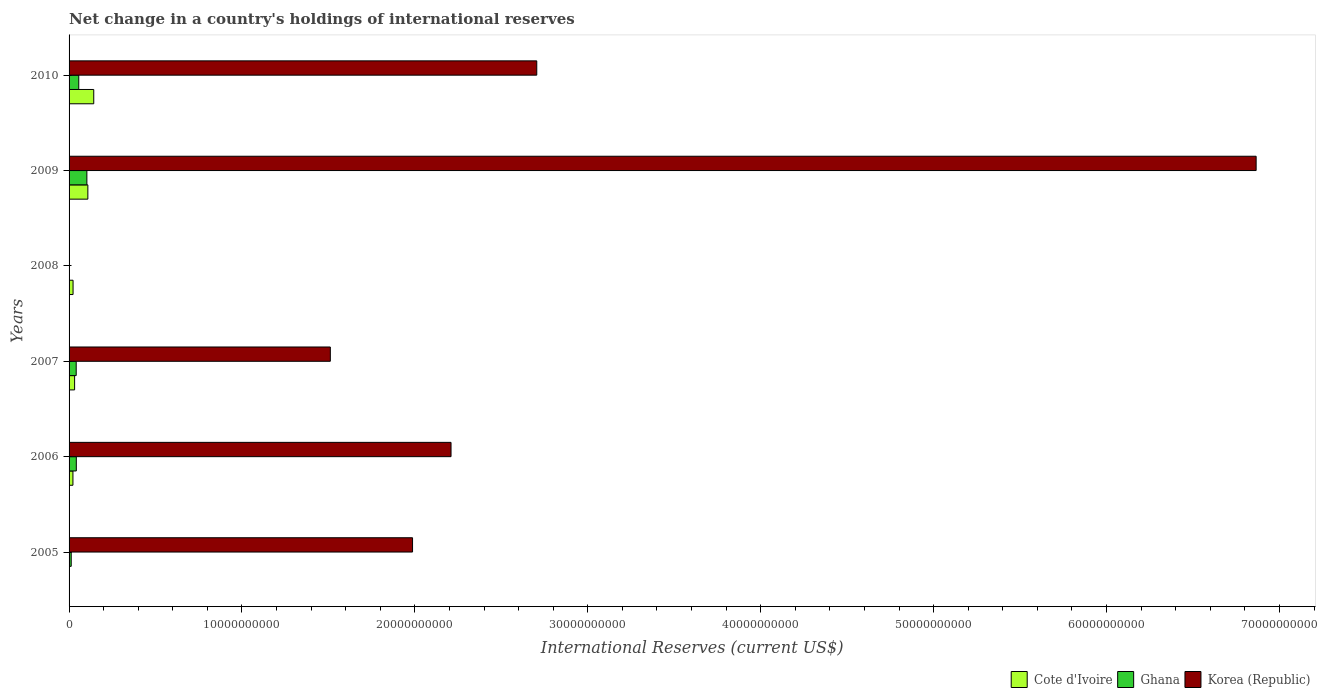How many different coloured bars are there?
Your response must be concise. 3. Are the number of bars per tick equal to the number of legend labels?
Offer a terse response. No. Are the number of bars on each tick of the Y-axis equal?
Your answer should be very brief. No. What is the label of the 3rd group of bars from the top?
Provide a succinct answer. 2008. In how many cases, is the number of bars for a given year not equal to the number of legend labels?
Your answer should be compact. 2. What is the international reserves in Cote d'Ivoire in 2006?
Offer a very short reply. 2.23e+08. Across all years, what is the maximum international reserves in Ghana?
Give a very brief answer. 1.03e+09. Across all years, what is the minimum international reserves in Ghana?
Your response must be concise. 0. What is the total international reserves in Korea (Republic) in the graph?
Make the answer very short. 1.53e+11. What is the difference between the international reserves in Ghana in 2007 and that in 2010?
Offer a very short reply. -1.48e+08. What is the difference between the international reserves in Ghana in 2009 and the international reserves in Cote d'Ivoire in 2008?
Offer a very short reply. 7.99e+08. What is the average international reserves in Cote d'Ivoire per year?
Your answer should be very brief. 5.48e+08. In the year 2010, what is the difference between the international reserves in Korea (Republic) and international reserves in Ghana?
Keep it short and to the point. 2.65e+1. What is the ratio of the international reserves in Ghana in 2007 to that in 2009?
Provide a short and direct response. 0.4. What is the difference between the highest and the second highest international reserves in Korea (Republic)?
Offer a very short reply. 4.16e+1. What is the difference between the highest and the lowest international reserves in Ghana?
Provide a succinct answer. 1.03e+09. In how many years, is the international reserves in Korea (Republic) greater than the average international reserves in Korea (Republic) taken over all years?
Provide a short and direct response. 2. Is it the case that in every year, the sum of the international reserves in Korea (Republic) and international reserves in Ghana is greater than the international reserves in Cote d'Ivoire?
Provide a short and direct response. No. How many bars are there?
Offer a terse response. 15. Are all the bars in the graph horizontal?
Your answer should be very brief. Yes. How many years are there in the graph?
Your answer should be very brief. 6. What is the difference between two consecutive major ticks on the X-axis?
Your answer should be compact. 1.00e+1. Does the graph contain any zero values?
Offer a very short reply. Yes. Does the graph contain grids?
Provide a short and direct response. No. Where does the legend appear in the graph?
Make the answer very short. Bottom right. How are the legend labels stacked?
Keep it short and to the point. Horizontal. What is the title of the graph?
Make the answer very short. Net change in a country's holdings of international reserves. Does "Monaco" appear as one of the legend labels in the graph?
Ensure brevity in your answer.  No. What is the label or title of the X-axis?
Provide a succinct answer. International Reserves (current US$). What is the International Reserves (current US$) of Ghana in 2005?
Ensure brevity in your answer.  1.25e+08. What is the International Reserves (current US$) of Korea (Republic) in 2005?
Give a very brief answer. 1.99e+1. What is the International Reserves (current US$) in Cote d'Ivoire in 2006?
Your response must be concise. 2.23e+08. What is the International Reserves (current US$) in Ghana in 2006?
Provide a succinct answer. 4.18e+08. What is the International Reserves (current US$) in Korea (Republic) in 2006?
Ensure brevity in your answer.  2.21e+1. What is the International Reserves (current US$) of Cote d'Ivoire in 2007?
Give a very brief answer. 3.21e+08. What is the International Reserves (current US$) in Ghana in 2007?
Your answer should be very brief. 4.12e+08. What is the International Reserves (current US$) of Korea (Republic) in 2007?
Ensure brevity in your answer.  1.51e+1. What is the International Reserves (current US$) of Cote d'Ivoire in 2008?
Your answer should be very brief. 2.30e+08. What is the International Reserves (current US$) in Ghana in 2008?
Ensure brevity in your answer.  0. What is the International Reserves (current US$) in Cote d'Ivoire in 2009?
Your answer should be very brief. 1.09e+09. What is the International Reserves (current US$) in Ghana in 2009?
Your answer should be very brief. 1.03e+09. What is the International Reserves (current US$) of Korea (Republic) in 2009?
Offer a very short reply. 6.87e+1. What is the International Reserves (current US$) of Cote d'Ivoire in 2010?
Provide a short and direct response. 1.43e+09. What is the International Reserves (current US$) of Ghana in 2010?
Your answer should be very brief. 5.61e+08. What is the International Reserves (current US$) of Korea (Republic) in 2010?
Keep it short and to the point. 2.70e+1. Across all years, what is the maximum International Reserves (current US$) in Cote d'Ivoire?
Your answer should be compact. 1.43e+09. Across all years, what is the maximum International Reserves (current US$) of Ghana?
Provide a short and direct response. 1.03e+09. Across all years, what is the maximum International Reserves (current US$) in Korea (Republic)?
Provide a succinct answer. 6.87e+1. Across all years, what is the minimum International Reserves (current US$) in Korea (Republic)?
Offer a terse response. 0. What is the total International Reserves (current US$) of Cote d'Ivoire in the graph?
Provide a short and direct response. 3.29e+09. What is the total International Reserves (current US$) of Ghana in the graph?
Offer a very short reply. 2.55e+09. What is the total International Reserves (current US$) in Korea (Republic) in the graph?
Your answer should be very brief. 1.53e+11. What is the difference between the International Reserves (current US$) in Ghana in 2005 and that in 2006?
Ensure brevity in your answer.  -2.94e+08. What is the difference between the International Reserves (current US$) of Korea (Republic) in 2005 and that in 2006?
Provide a short and direct response. -2.23e+09. What is the difference between the International Reserves (current US$) of Ghana in 2005 and that in 2007?
Make the answer very short. -2.88e+08. What is the difference between the International Reserves (current US$) in Korea (Republic) in 2005 and that in 2007?
Offer a terse response. 4.75e+09. What is the difference between the International Reserves (current US$) of Ghana in 2005 and that in 2009?
Provide a short and direct response. -9.05e+08. What is the difference between the International Reserves (current US$) of Korea (Republic) in 2005 and that in 2009?
Keep it short and to the point. -4.88e+1. What is the difference between the International Reserves (current US$) in Ghana in 2005 and that in 2010?
Your response must be concise. -4.36e+08. What is the difference between the International Reserves (current US$) in Korea (Republic) in 2005 and that in 2010?
Your answer should be very brief. -7.18e+09. What is the difference between the International Reserves (current US$) of Cote d'Ivoire in 2006 and that in 2007?
Offer a terse response. -9.74e+07. What is the difference between the International Reserves (current US$) of Ghana in 2006 and that in 2007?
Offer a very short reply. 5.98e+06. What is the difference between the International Reserves (current US$) of Korea (Republic) in 2006 and that in 2007?
Offer a terse response. 6.98e+09. What is the difference between the International Reserves (current US$) of Cote d'Ivoire in 2006 and that in 2008?
Your answer should be very brief. -7.15e+06. What is the difference between the International Reserves (current US$) of Cote d'Ivoire in 2006 and that in 2009?
Your response must be concise. -8.63e+08. What is the difference between the International Reserves (current US$) of Ghana in 2006 and that in 2009?
Give a very brief answer. -6.11e+08. What is the difference between the International Reserves (current US$) of Korea (Republic) in 2006 and that in 2009?
Provide a succinct answer. -4.66e+1. What is the difference between the International Reserves (current US$) in Cote d'Ivoire in 2006 and that in 2010?
Provide a short and direct response. -1.20e+09. What is the difference between the International Reserves (current US$) of Ghana in 2006 and that in 2010?
Offer a terse response. -1.42e+08. What is the difference between the International Reserves (current US$) of Korea (Republic) in 2006 and that in 2010?
Give a very brief answer. -4.96e+09. What is the difference between the International Reserves (current US$) in Cote d'Ivoire in 2007 and that in 2008?
Your response must be concise. 9.02e+07. What is the difference between the International Reserves (current US$) of Cote d'Ivoire in 2007 and that in 2009?
Your answer should be very brief. -7.66e+08. What is the difference between the International Reserves (current US$) in Ghana in 2007 and that in 2009?
Ensure brevity in your answer.  -6.17e+08. What is the difference between the International Reserves (current US$) of Korea (Republic) in 2007 and that in 2009?
Your answer should be very brief. -5.35e+1. What is the difference between the International Reserves (current US$) of Cote d'Ivoire in 2007 and that in 2010?
Provide a succinct answer. -1.11e+09. What is the difference between the International Reserves (current US$) of Ghana in 2007 and that in 2010?
Make the answer very short. -1.48e+08. What is the difference between the International Reserves (current US$) in Korea (Republic) in 2007 and that in 2010?
Offer a very short reply. -1.19e+1. What is the difference between the International Reserves (current US$) of Cote d'Ivoire in 2008 and that in 2009?
Your answer should be very brief. -8.56e+08. What is the difference between the International Reserves (current US$) of Cote d'Ivoire in 2008 and that in 2010?
Provide a short and direct response. -1.20e+09. What is the difference between the International Reserves (current US$) of Cote d'Ivoire in 2009 and that in 2010?
Provide a succinct answer. -3.41e+08. What is the difference between the International Reserves (current US$) in Ghana in 2009 and that in 2010?
Your answer should be compact. 4.69e+08. What is the difference between the International Reserves (current US$) in Korea (Republic) in 2009 and that in 2010?
Your answer should be compact. 4.16e+1. What is the difference between the International Reserves (current US$) of Ghana in 2005 and the International Reserves (current US$) of Korea (Republic) in 2006?
Provide a short and direct response. -2.20e+1. What is the difference between the International Reserves (current US$) of Ghana in 2005 and the International Reserves (current US$) of Korea (Republic) in 2007?
Provide a short and direct response. -1.50e+1. What is the difference between the International Reserves (current US$) of Ghana in 2005 and the International Reserves (current US$) of Korea (Republic) in 2009?
Provide a succinct answer. -6.85e+1. What is the difference between the International Reserves (current US$) of Ghana in 2005 and the International Reserves (current US$) of Korea (Republic) in 2010?
Keep it short and to the point. -2.69e+1. What is the difference between the International Reserves (current US$) of Cote d'Ivoire in 2006 and the International Reserves (current US$) of Ghana in 2007?
Keep it short and to the point. -1.89e+08. What is the difference between the International Reserves (current US$) in Cote d'Ivoire in 2006 and the International Reserves (current US$) in Korea (Republic) in 2007?
Provide a short and direct response. -1.49e+1. What is the difference between the International Reserves (current US$) in Ghana in 2006 and the International Reserves (current US$) in Korea (Republic) in 2007?
Make the answer very short. -1.47e+1. What is the difference between the International Reserves (current US$) of Cote d'Ivoire in 2006 and the International Reserves (current US$) of Ghana in 2009?
Your answer should be very brief. -8.06e+08. What is the difference between the International Reserves (current US$) of Cote d'Ivoire in 2006 and the International Reserves (current US$) of Korea (Republic) in 2009?
Your response must be concise. -6.84e+1. What is the difference between the International Reserves (current US$) in Ghana in 2006 and the International Reserves (current US$) in Korea (Republic) in 2009?
Give a very brief answer. -6.82e+1. What is the difference between the International Reserves (current US$) of Cote d'Ivoire in 2006 and the International Reserves (current US$) of Ghana in 2010?
Offer a terse response. -3.37e+08. What is the difference between the International Reserves (current US$) in Cote d'Ivoire in 2006 and the International Reserves (current US$) in Korea (Republic) in 2010?
Make the answer very short. -2.68e+1. What is the difference between the International Reserves (current US$) of Ghana in 2006 and the International Reserves (current US$) of Korea (Republic) in 2010?
Your answer should be very brief. -2.66e+1. What is the difference between the International Reserves (current US$) of Cote d'Ivoire in 2007 and the International Reserves (current US$) of Ghana in 2009?
Your answer should be compact. -7.09e+08. What is the difference between the International Reserves (current US$) of Cote d'Ivoire in 2007 and the International Reserves (current US$) of Korea (Republic) in 2009?
Ensure brevity in your answer.  -6.83e+1. What is the difference between the International Reserves (current US$) of Ghana in 2007 and the International Reserves (current US$) of Korea (Republic) in 2009?
Ensure brevity in your answer.  -6.82e+1. What is the difference between the International Reserves (current US$) in Cote d'Ivoire in 2007 and the International Reserves (current US$) in Ghana in 2010?
Your answer should be compact. -2.40e+08. What is the difference between the International Reserves (current US$) in Cote d'Ivoire in 2007 and the International Reserves (current US$) in Korea (Republic) in 2010?
Make the answer very short. -2.67e+1. What is the difference between the International Reserves (current US$) in Ghana in 2007 and the International Reserves (current US$) in Korea (Republic) in 2010?
Your response must be concise. -2.66e+1. What is the difference between the International Reserves (current US$) of Cote d'Ivoire in 2008 and the International Reserves (current US$) of Ghana in 2009?
Provide a short and direct response. -7.99e+08. What is the difference between the International Reserves (current US$) in Cote d'Ivoire in 2008 and the International Reserves (current US$) in Korea (Republic) in 2009?
Provide a succinct answer. -6.84e+1. What is the difference between the International Reserves (current US$) of Cote d'Ivoire in 2008 and the International Reserves (current US$) of Ghana in 2010?
Your answer should be very brief. -3.30e+08. What is the difference between the International Reserves (current US$) of Cote d'Ivoire in 2008 and the International Reserves (current US$) of Korea (Republic) in 2010?
Your answer should be compact. -2.68e+1. What is the difference between the International Reserves (current US$) in Cote d'Ivoire in 2009 and the International Reserves (current US$) in Ghana in 2010?
Your answer should be very brief. 5.26e+08. What is the difference between the International Reserves (current US$) of Cote d'Ivoire in 2009 and the International Reserves (current US$) of Korea (Republic) in 2010?
Provide a short and direct response. -2.60e+1. What is the difference between the International Reserves (current US$) of Ghana in 2009 and the International Reserves (current US$) of Korea (Republic) in 2010?
Your response must be concise. -2.60e+1. What is the average International Reserves (current US$) in Cote d'Ivoire per year?
Offer a terse response. 5.48e+08. What is the average International Reserves (current US$) of Ghana per year?
Your response must be concise. 4.24e+08. What is the average International Reserves (current US$) of Korea (Republic) per year?
Provide a short and direct response. 2.55e+1. In the year 2005, what is the difference between the International Reserves (current US$) in Ghana and International Reserves (current US$) in Korea (Republic)?
Provide a succinct answer. -1.97e+1. In the year 2006, what is the difference between the International Reserves (current US$) in Cote d'Ivoire and International Reserves (current US$) in Ghana?
Give a very brief answer. -1.95e+08. In the year 2006, what is the difference between the International Reserves (current US$) of Cote d'Ivoire and International Reserves (current US$) of Korea (Republic)?
Your answer should be compact. -2.19e+1. In the year 2006, what is the difference between the International Reserves (current US$) of Ghana and International Reserves (current US$) of Korea (Republic)?
Offer a terse response. -2.17e+1. In the year 2007, what is the difference between the International Reserves (current US$) of Cote d'Ivoire and International Reserves (current US$) of Ghana?
Your response must be concise. -9.18e+07. In the year 2007, what is the difference between the International Reserves (current US$) in Cote d'Ivoire and International Reserves (current US$) in Korea (Republic)?
Make the answer very short. -1.48e+1. In the year 2007, what is the difference between the International Reserves (current US$) in Ghana and International Reserves (current US$) in Korea (Republic)?
Provide a succinct answer. -1.47e+1. In the year 2009, what is the difference between the International Reserves (current US$) in Cote d'Ivoire and International Reserves (current US$) in Ghana?
Give a very brief answer. 5.72e+07. In the year 2009, what is the difference between the International Reserves (current US$) in Cote d'Ivoire and International Reserves (current US$) in Korea (Republic)?
Give a very brief answer. -6.76e+1. In the year 2009, what is the difference between the International Reserves (current US$) in Ghana and International Reserves (current US$) in Korea (Republic)?
Give a very brief answer. -6.76e+1. In the year 2010, what is the difference between the International Reserves (current US$) of Cote d'Ivoire and International Reserves (current US$) of Ghana?
Your response must be concise. 8.67e+08. In the year 2010, what is the difference between the International Reserves (current US$) of Cote d'Ivoire and International Reserves (current US$) of Korea (Republic)?
Your response must be concise. -2.56e+1. In the year 2010, what is the difference between the International Reserves (current US$) of Ghana and International Reserves (current US$) of Korea (Republic)?
Offer a very short reply. -2.65e+1. What is the ratio of the International Reserves (current US$) in Ghana in 2005 to that in 2006?
Provide a short and direct response. 0.3. What is the ratio of the International Reserves (current US$) of Korea (Republic) in 2005 to that in 2006?
Provide a short and direct response. 0.9. What is the ratio of the International Reserves (current US$) of Ghana in 2005 to that in 2007?
Offer a very short reply. 0.3. What is the ratio of the International Reserves (current US$) of Korea (Republic) in 2005 to that in 2007?
Your answer should be very brief. 1.31. What is the ratio of the International Reserves (current US$) of Ghana in 2005 to that in 2009?
Your answer should be very brief. 0.12. What is the ratio of the International Reserves (current US$) of Korea (Republic) in 2005 to that in 2009?
Ensure brevity in your answer.  0.29. What is the ratio of the International Reserves (current US$) of Ghana in 2005 to that in 2010?
Provide a short and direct response. 0.22. What is the ratio of the International Reserves (current US$) of Korea (Republic) in 2005 to that in 2010?
Provide a short and direct response. 0.73. What is the ratio of the International Reserves (current US$) in Cote d'Ivoire in 2006 to that in 2007?
Offer a terse response. 0.7. What is the ratio of the International Reserves (current US$) of Ghana in 2006 to that in 2007?
Ensure brevity in your answer.  1.01. What is the ratio of the International Reserves (current US$) of Korea (Republic) in 2006 to that in 2007?
Your response must be concise. 1.46. What is the ratio of the International Reserves (current US$) of Cote d'Ivoire in 2006 to that in 2008?
Ensure brevity in your answer.  0.97. What is the ratio of the International Reserves (current US$) in Cote d'Ivoire in 2006 to that in 2009?
Offer a very short reply. 0.21. What is the ratio of the International Reserves (current US$) of Ghana in 2006 to that in 2009?
Your answer should be very brief. 0.41. What is the ratio of the International Reserves (current US$) in Korea (Republic) in 2006 to that in 2009?
Ensure brevity in your answer.  0.32. What is the ratio of the International Reserves (current US$) of Cote d'Ivoire in 2006 to that in 2010?
Your answer should be very brief. 0.16. What is the ratio of the International Reserves (current US$) in Ghana in 2006 to that in 2010?
Your response must be concise. 0.75. What is the ratio of the International Reserves (current US$) in Korea (Republic) in 2006 to that in 2010?
Provide a succinct answer. 0.82. What is the ratio of the International Reserves (current US$) in Cote d'Ivoire in 2007 to that in 2008?
Offer a terse response. 1.39. What is the ratio of the International Reserves (current US$) of Cote d'Ivoire in 2007 to that in 2009?
Ensure brevity in your answer.  0.3. What is the ratio of the International Reserves (current US$) of Ghana in 2007 to that in 2009?
Your answer should be compact. 0.4. What is the ratio of the International Reserves (current US$) in Korea (Republic) in 2007 to that in 2009?
Make the answer very short. 0.22. What is the ratio of the International Reserves (current US$) in Cote d'Ivoire in 2007 to that in 2010?
Keep it short and to the point. 0.22. What is the ratio of the International Reserves (current US$) in Ghana in 2007 to that in 2010?
Provide a succinct answer. 0.74. What is the ratio of the International Reserves (current US$) of Korea (Republic) in 2007 to that in 2010?
Offer a terse response. 0.56. What is the ratio of the International Reserves (current US$) in Cote d'Ivoire in 2008 to that in 2009?
Offer a very short reply. 0.21. What is the ratio of the International Reserves (current US$) in Cote d'Ivoire in 2008 to that in 2010?
Your response must be concise. 0.16. What is the ratio of the International Reserves (current US$) of Cote d'Ivoire in 2009 to that in 2010?
Offer a terse response. 0.76. What is the ratio of the International Reserves (current US$) of Ghana in 2009 to that in 2010?
Keep it short and to the point. 1.84. What is the ratio of the International Reserves (current US$) of Korea (Republic) in 2009 to that in 2010?
Provide a succinct answer. 2.54. What is the difference between the highest and the second highest International Reserves (current US$) in Cote d'Ivoire?
Make the answer very short. 3.41e+08. What is the difference between the highest and the second highest International Reserves (current US$) of Ghana?
Provide a succinct answer. 4.69e+08. What is the difference between the highest and the second highest International Reserves (current US$) of Korea (Republic)?
Make the answer very short. 4.16e+1. What is the difference between the highest and the lowest International Reserves (current US$) in Cote d'Ivoire?
Make the answer very short. 1.43e+09. What is the difference between the highest and the lowest International Reserves (current US$) in Ghana?
Keep it short and to the point. 1.03e+09. What is the difference between the highest and the lowest International Reserves (current US$) in Korea (Republic)?
Offer a terse response. 6.87e+1. 